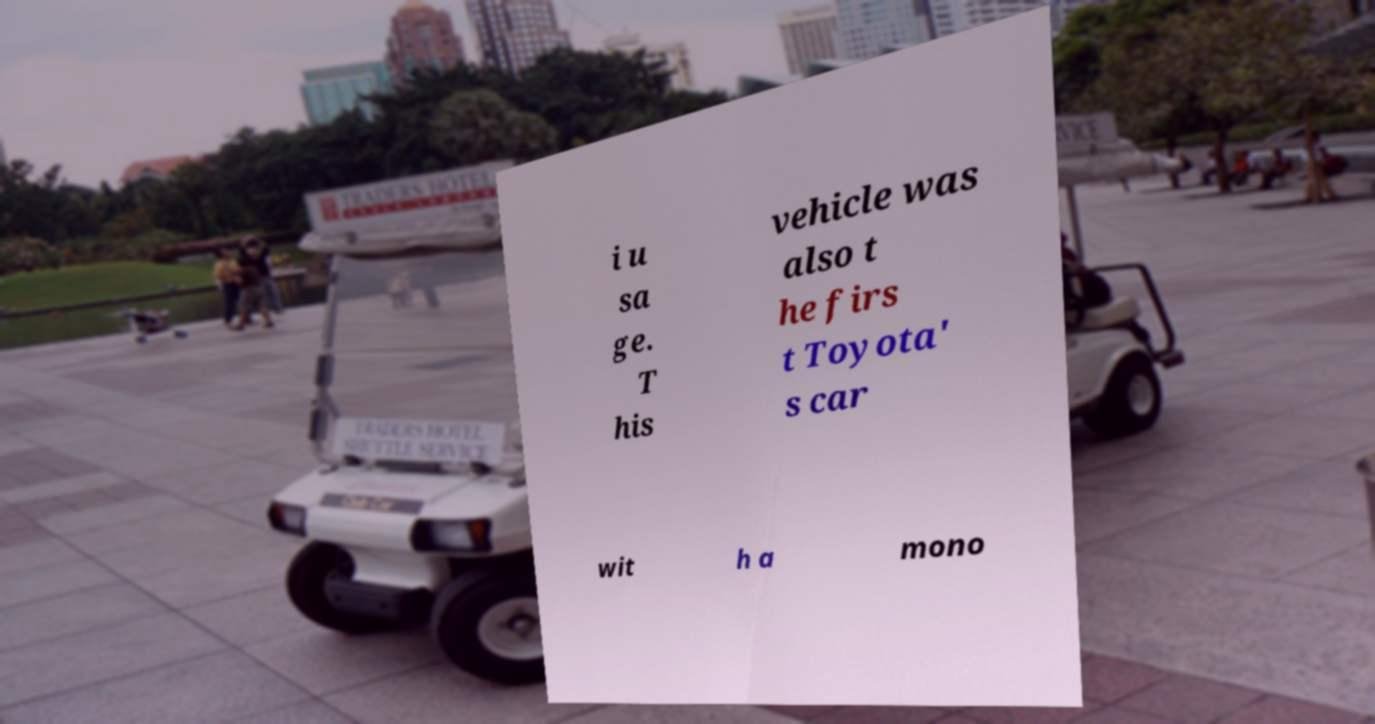Could you extract and type out the text from this image? i u sa ge. T his vehicle was also t he firs t Toyota' s car wit h a mono 